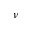Convert formula to latex. <formula><loc_0><loc_0><loc_500><loc_500>\nu</formula> 